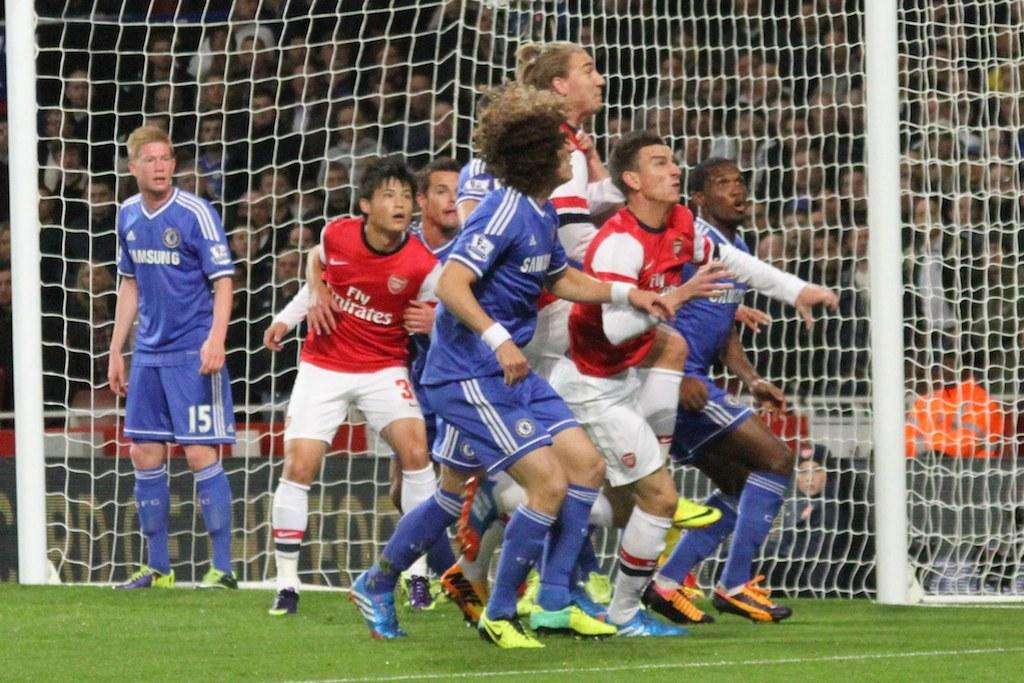Provide a one-sentence caption for the provided image. The team in blue wearing Samsung jersey's are playing against the team in red. 